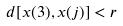<formula> <loc_0><loc_0><loc_500><loc_500>d [ x ( 3 ) , x ( j ) ] < r</formula> 